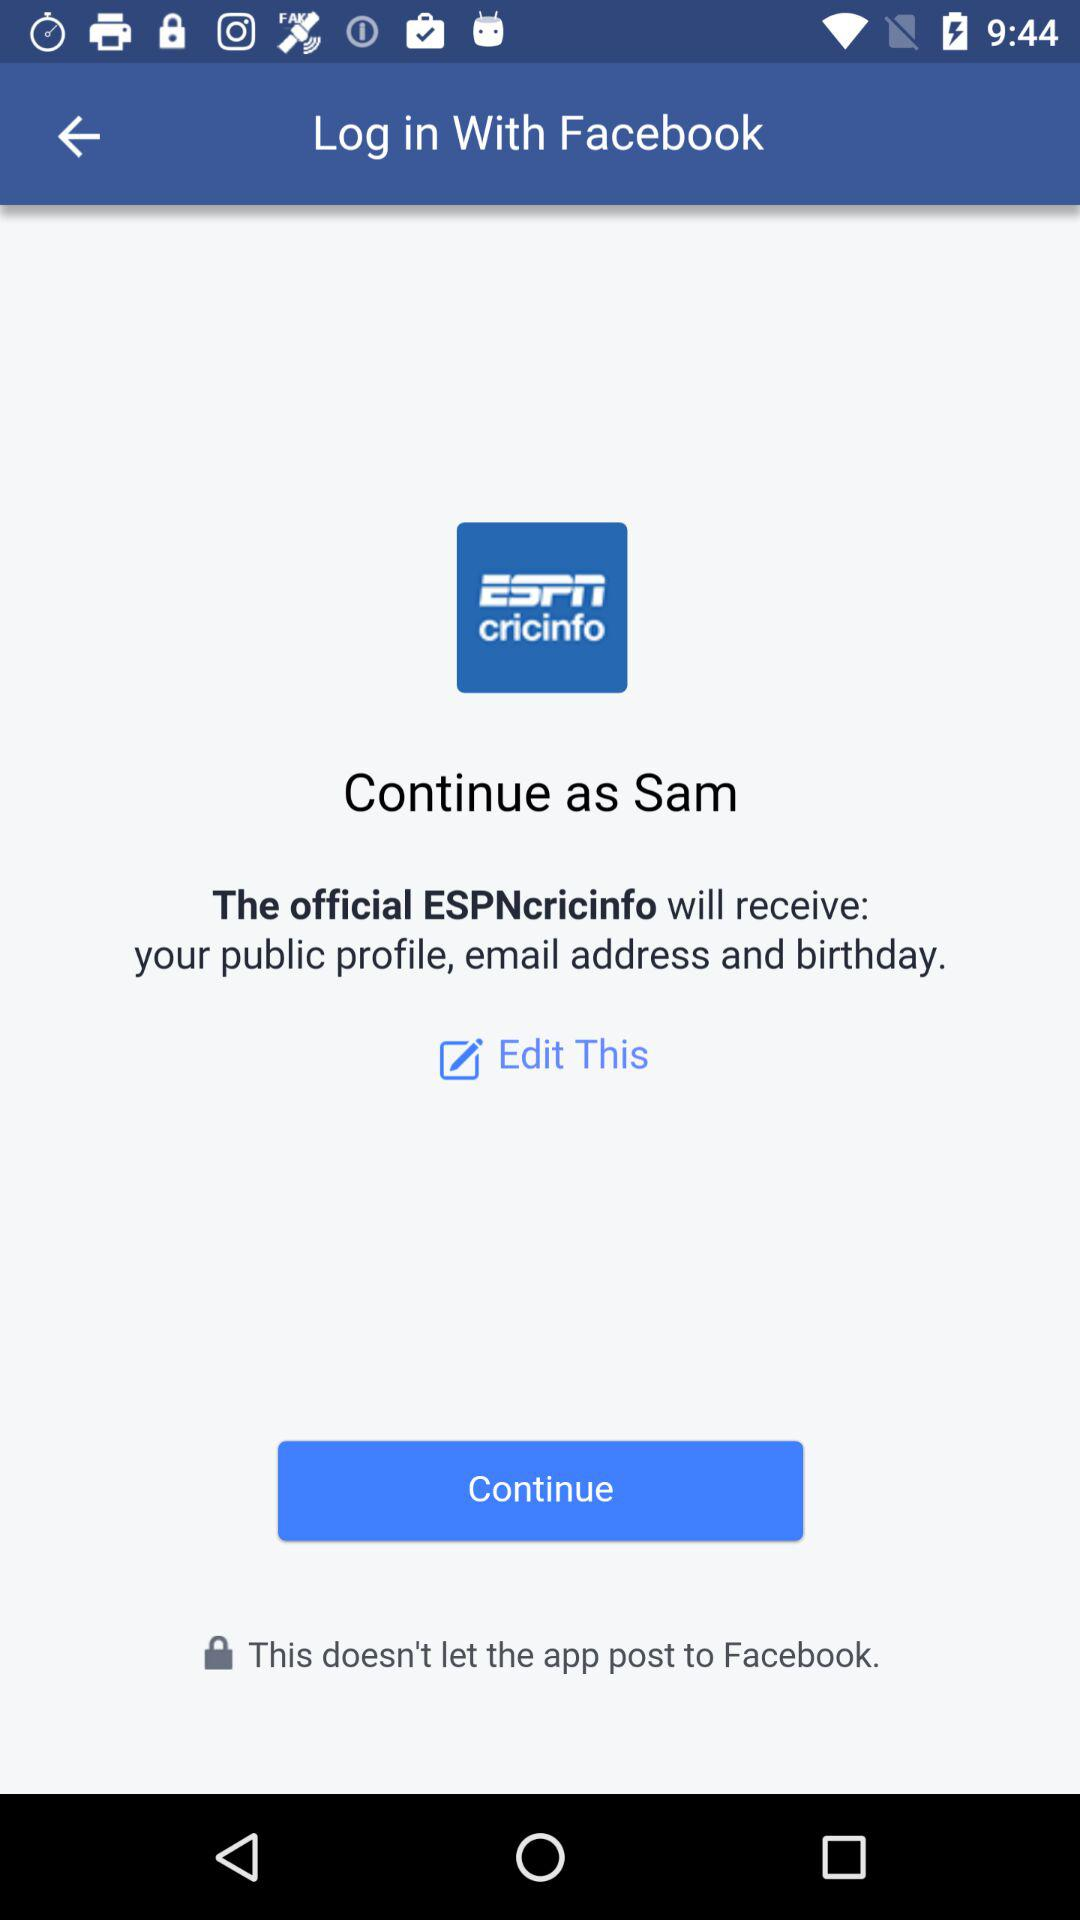How much does it cost to log in with "Facebook"?
When the provided information is insufficient, respond with <no answer>. <no answer> 